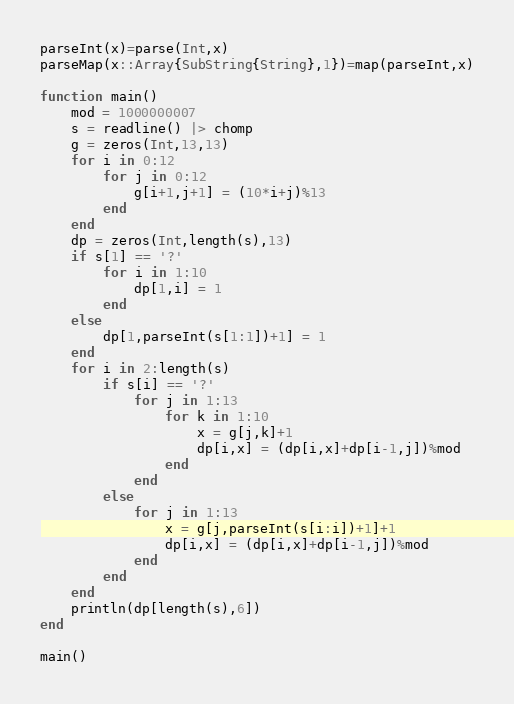<code> <loc_0><loc_0><loc_500><loc_500><_Julia_>parseInt(x)=parse(Int,x)
parseMap(x::Array{SubString{String},1})=map(parseInt,x)

function main()
	mod = 1000000007
	s = readline() |> chomp
	g = zeros(Int,13,13)
	for i in 0:12
		for j in 0:12
			g[i+1,j+1] = (10*i+j)%13
		end
	end
	dp = zeros(Int,length(s),13)
	if s[1] == '?'
		for i in 1:10
			dp[1,i] = 1
		end
	else
		dp[1,parseInt(s[1:1])+1] = 1
	end
	for i in 2:length(s)
		if s[i] == '?'
			for j in 1:13
				for k in 1:10
					x = g[j,k]+1
					dp[i,x] = (dp[i,x]+dp[i-1,j])%mod
				end
			end
		else
			for j in 1:13
				x = g[j,parseInt(s[i:i])+1]+1
				dp[i,x] = (dp[i,x]+dp[i-1,j])%mod
			end
		end
	end
	println(dp[length(s),6])
end

main()</code> 